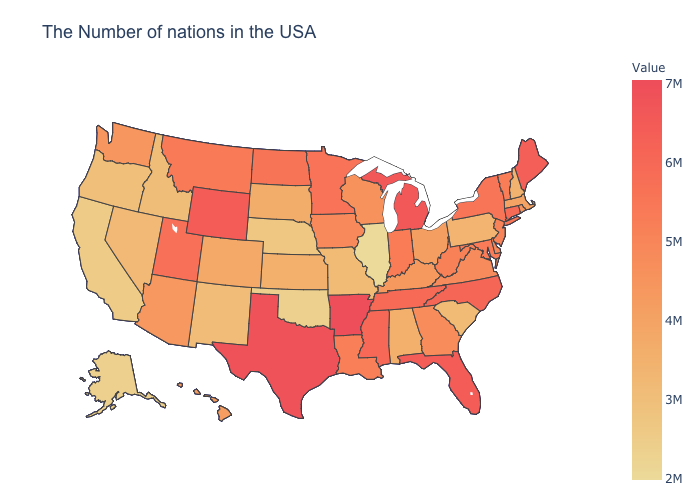Which states have the lowest value in the USA?
Answer briefly. Illinois. Does Ohio have the highest value in the MidWest?
Keep it brief. No. Among the states that border Delaware , which have the lowest value?
Concise answer only. Pennsylvania. Which states have the highest value in the USA?
Be succinct. Arkansas. 